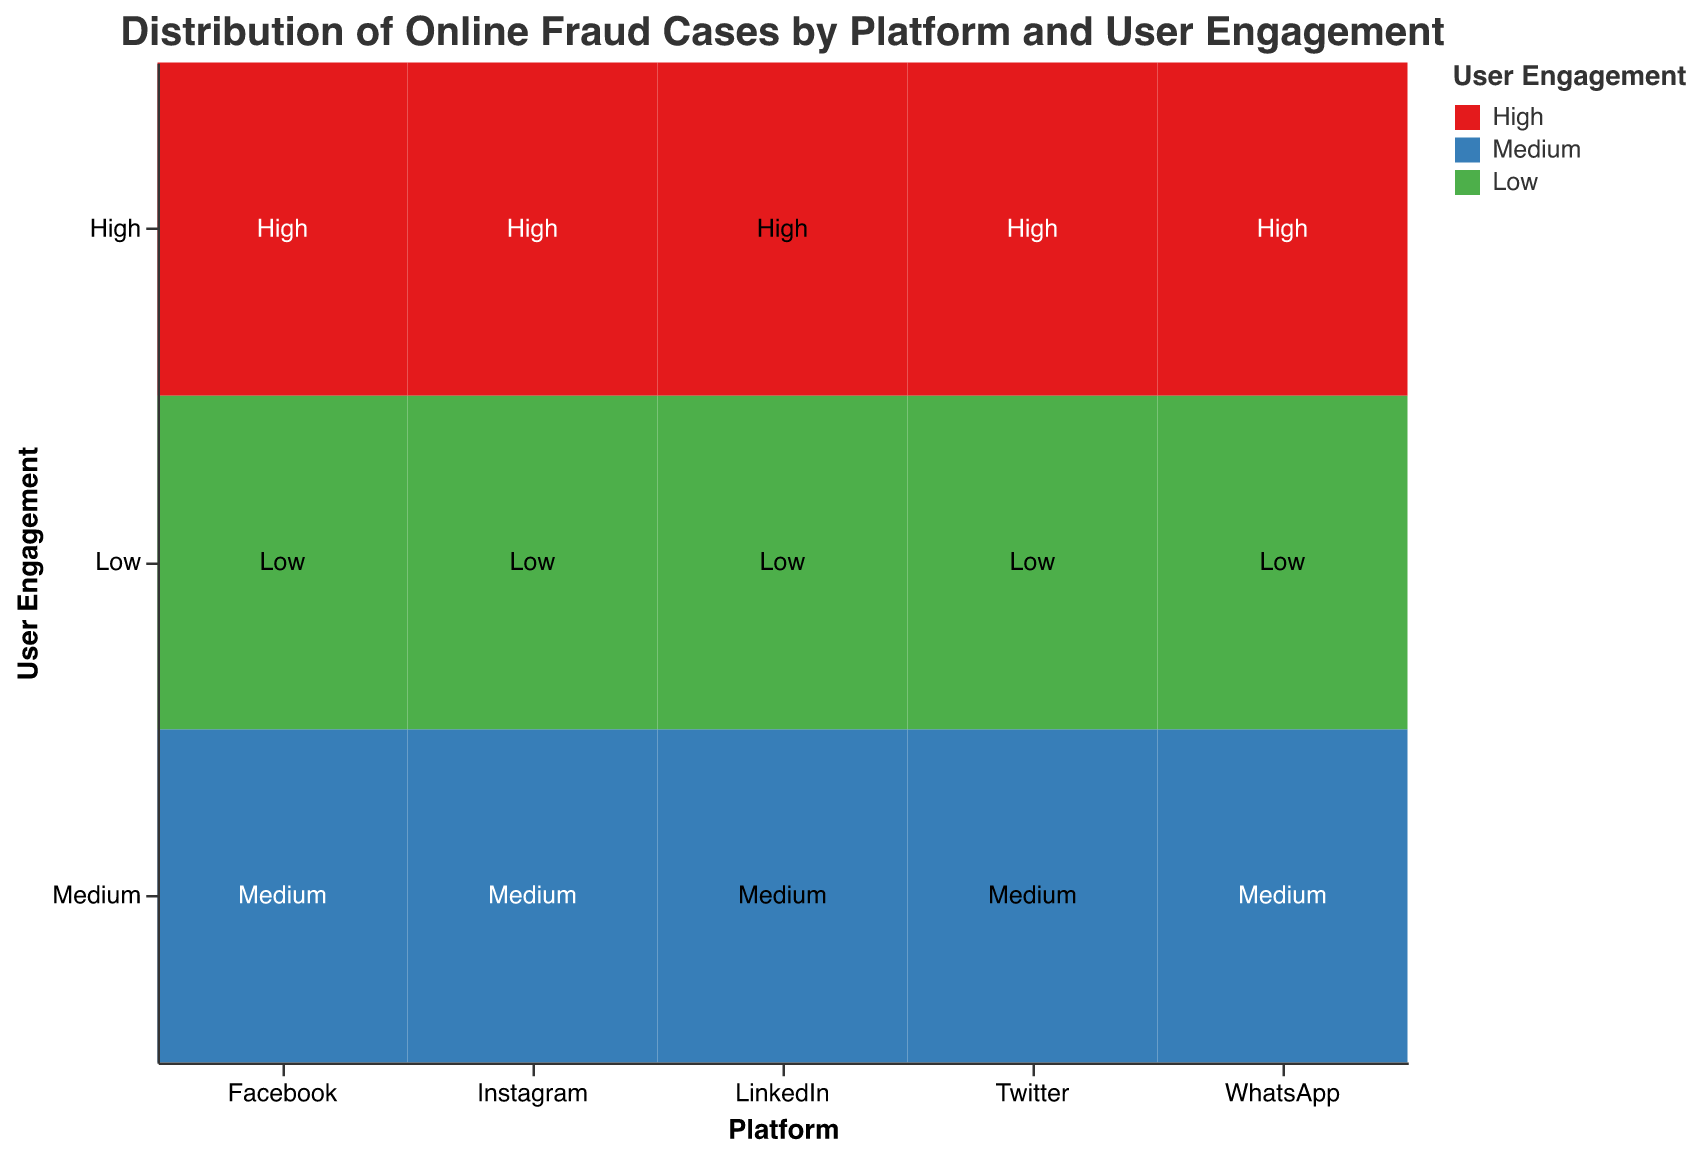What's the title of the figure? The title is usually displayed at the top of the figure, summarizing its content. By identifying the title, we understand the main topic the figure represents.
Answer: Distribution of Online Fraud Cases by Platform and User Engagement How are the axes labeled? Observing the labels on the x and y axes helps in understanding what dimensions the data is mapped onto. The x-axis label shows different platforms, and the y-axis shows user engagement levels.
Answer: The x-axis is labeled "Platform" and the y-axis is labeled "User Engagement." Which platform has the highest number of fraud cases with high user engagement? We look at each platform's "High" user engagement section to find the one with the maximum number of fraud cases. On the figure, the length or size of each bar for "High" user engagement on each platform will indicate the fraud cases.
Answer: Facebook Which platform and user engagement level has the least number of fraud cases? We need to identify the smallest dimension in the plot associated with any user engagement level. The smallest rectangle will represent the fewest cases.
Answer: LinkedIn with Low user engagement 